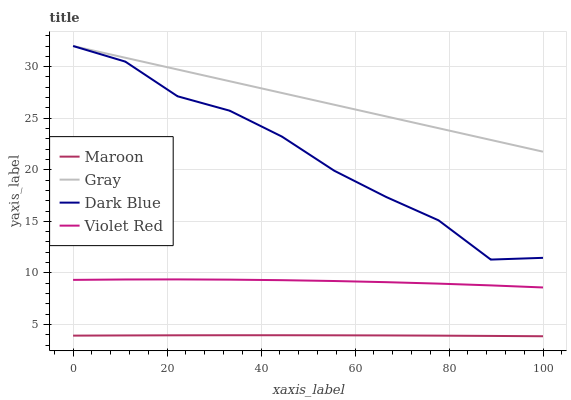Does Maroon have the minimum area under the curve?
Answer yes or no. Yes. Does Gray have the maximum area under the curve?
Answer yes or no. Yes. Does Violet Red have the minimum area under the curve?
Answer yes or no. No. Does Violet Red have the maximum area under the curve?
Answer yes or no. No. Is Gray the smoothest?
Answer yes or no. Yes. Is Dark Blue the roughest?
Answer yes or no. Yes. Is Violet Red the smoothest?
Answer yes or no. No. Is Violet Red the roughest?
Answer yes or no. No. Does Violet Red have the lowest value?
Answer yes or no. No. Does Dark Blue have the highest value?
Answer yes or no. Yes. Does Violet Red have the highest value?
Answer yes or no. No. Is Maroon less than Dark Blue?
Answer yes or no. Yes. Is Dark Blue greater than Maroon?
Answer yes or no. Yes. Does Gray intersect Dark Blue?
Answer yes or no. Yes. Is Gray less than Dark Blue?
Answer yes or no. No. Is Gray greater than Dark Blue?
Answer yes or no. No. Does Maroon intersect Dark Blue?
Answer yes or no. No. 